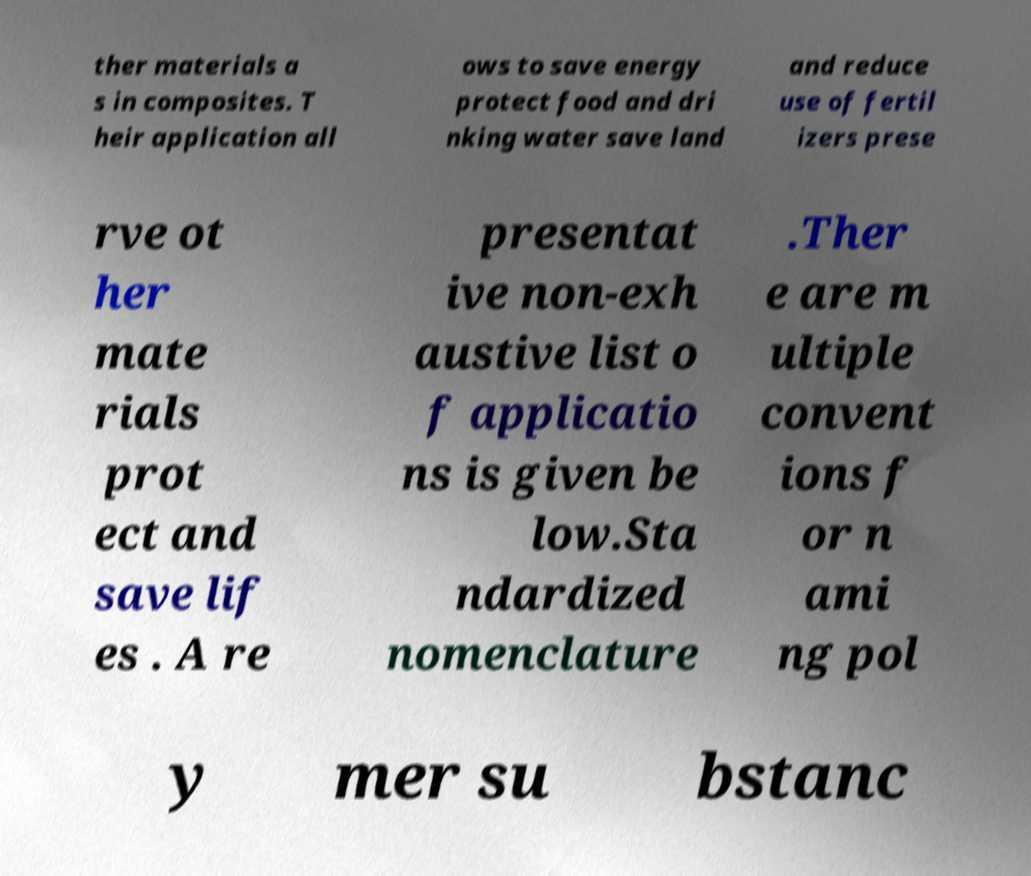What messages or text are displayed in this image? I need them in a readable, typed format. ther materials a s in composites. T heir application all ows to save energy protect food and dri nking water save land and reduce use of fertil izers prese rve ot her mate rials prot ect and save lif es . A re presentat ive non-exh austive list o f applicatio ns is given be low.Sta ndardized nomenclature .Ther e are m ultiple convent ions f or n ami ng pol y mer su bstanc 